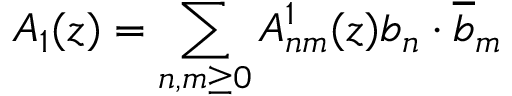<formula> <loc_0><loc_0><loc_500><loc_500>A _ { 1 } ( z ) = \sum _ { n , m \geq 0 } A _ { n m } ^ { 1 } ( z ) b _ { n } \cdot \overline { b } _ { m }</formula> 